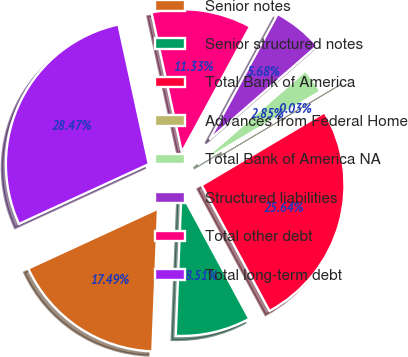<chart> <loc_0><loc_0><loc_500><loc_500><pie_chart><fcel>Senior notes<fcel>Senior structured notes<fcel>Total Bank of America<fcel>Advances from Federal Home<fcel>Total Bank of America NA<fcel>Structured liabilities<fcel>Total other debt<fcel>Total long-term debt<nl><fcel>17.49%<fcel>8.51%<fcel>25.64%<fcel>0.03%<fcel>2.85%<fcel>5.68%<fcel>11.33%<fcel>28.47%<nl></chart> 